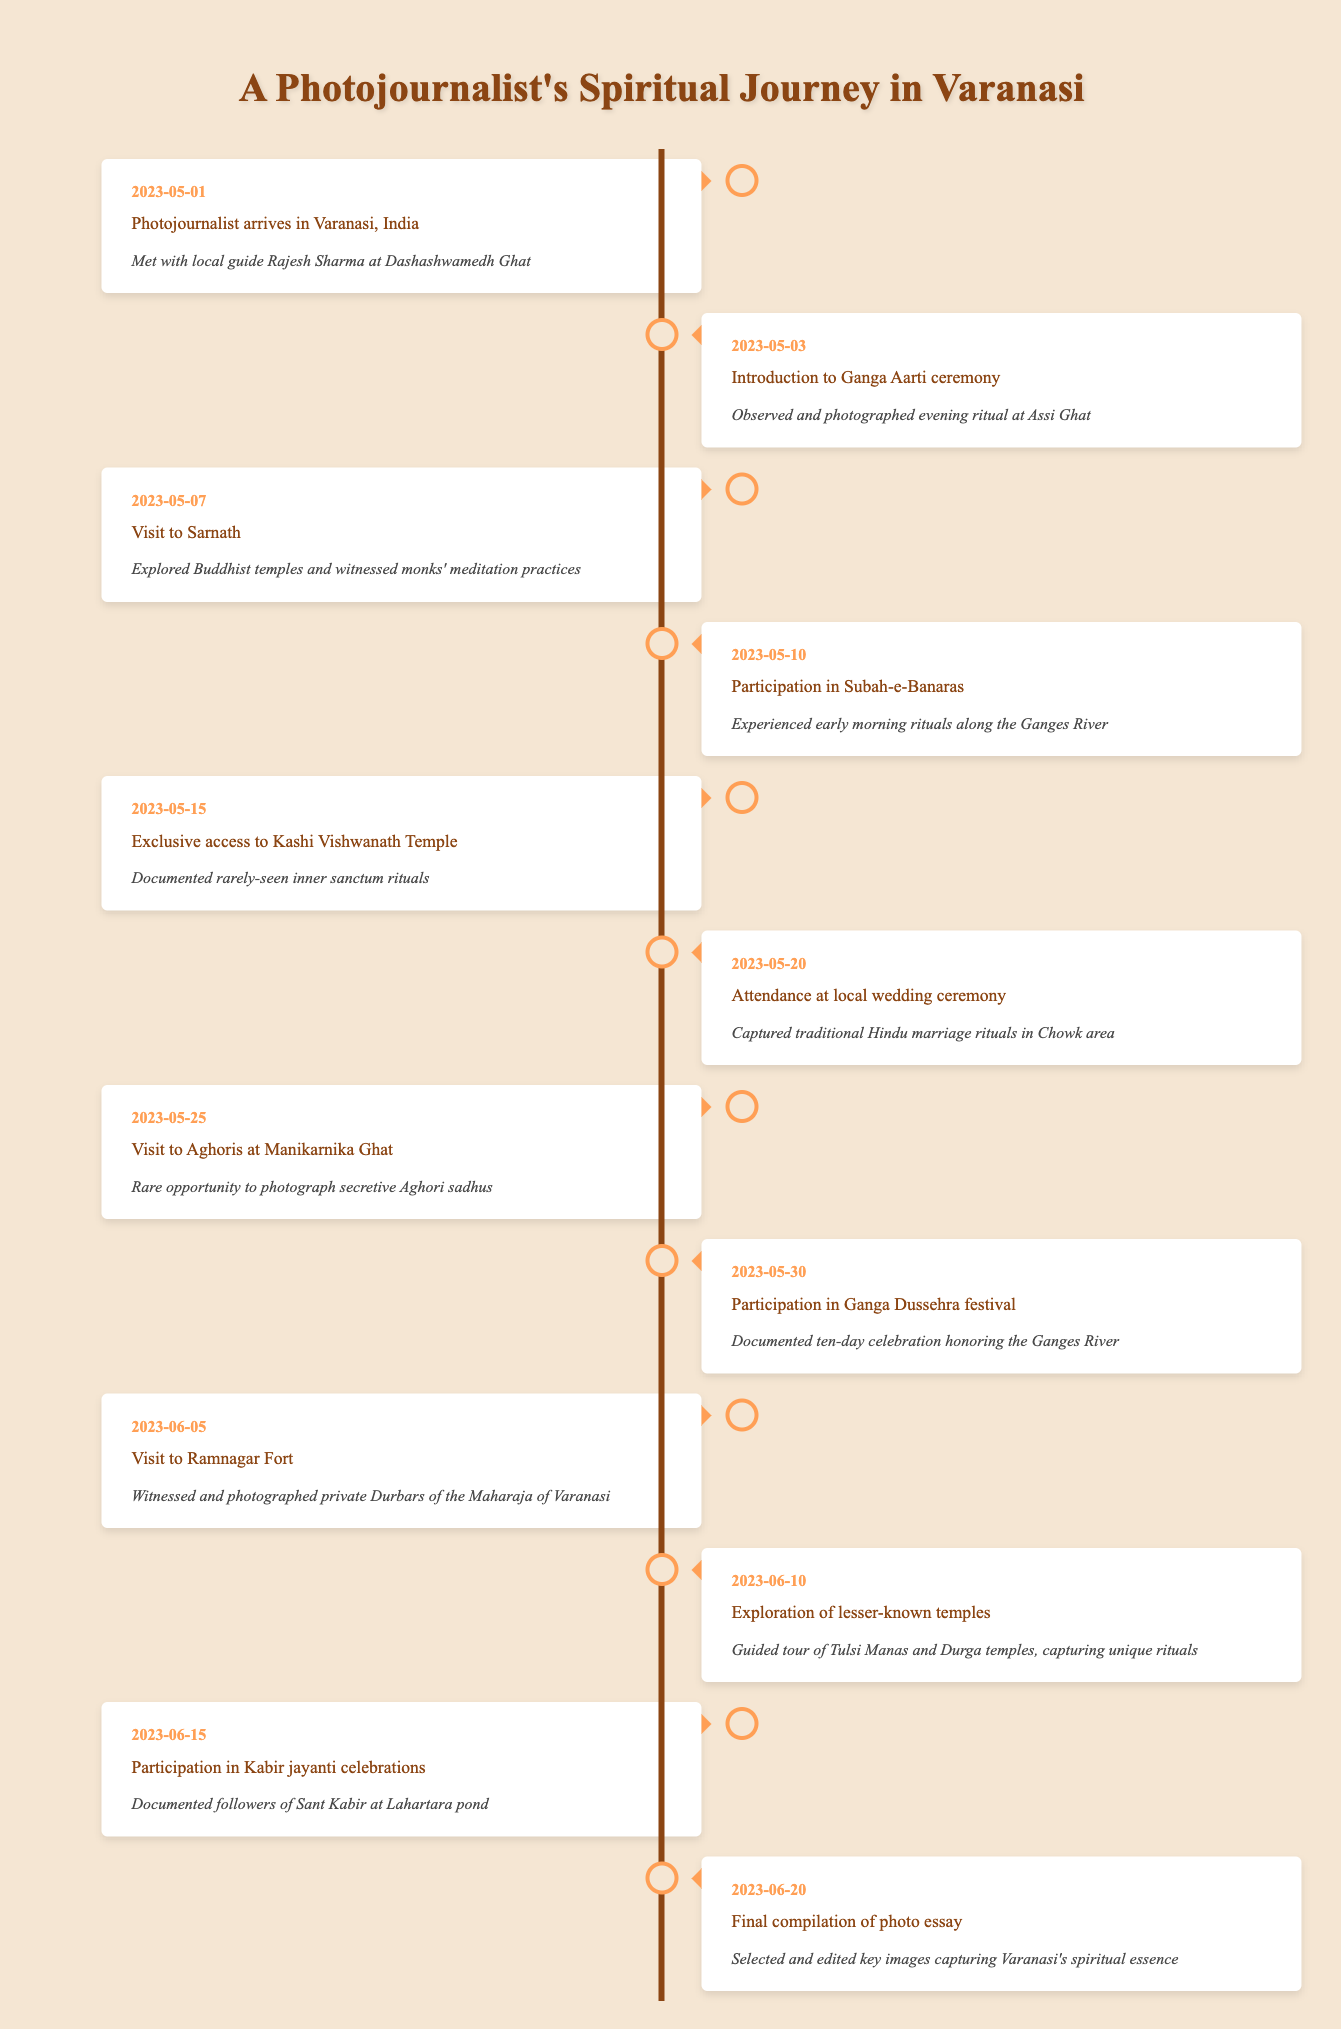What event took place on May 10, 2023? The table shows that on May 10, 2023, the event was "Participation in Subah-e-Banaras."
Answer: Participation in Subah-e-Banaras How many spiritual practices did the photojournalist experience by May 30, 2023? By May 30, 2023, the photojournalist experienced 5 distinct spiritual practices: Ganga Aarti, Sarnath visit, Subah-e-Banaras, Kashi Vishwanath Temple access, and Ganga Dussehra festival.
Answer: 5 Was the photojournalist able to document rituals at Kashi Vishwanath Temple? Yes, the photojournalist had exclusive access to document rarely-seen inner sanctum rituals at Kashi Vishwanath Temple.
Answer: Yes On what date did the photojournalist participate in the Ganga Dussehra festival? According to the table, the participation in the Ganga Dussehra festival took place on May 30, 2023.
Answer: May 30, 2023 What was the last event listed in the timeline? The last event in the timeline is "Final compilation of photo essay," which occurred on June 20, 2023.
Answer: Final compilation of photo essay How many days passed between the photojournalist’s arrival in Varanasi and the attendance at the local wedding ceremony? The photojournalist arrived in Varanasi on May 1, 2023, and attended the wedding ceremony on May 20, 2023. This is a duration of 19 days.
Answer: 19 days Did the photojournalist document any events related to Sant Kabir? Yes, the photojournalist participated in Kabir jayanti celebrations on June 15, 2023, documenting followers of Sant Kabir.
Answer: Yes Which two events occurred in the second week of May? The two events that occurred in the second week of May are the participation in Subah-e-Banaras on May 10 and the attendance at a local wedding ceremony on May 20.
Answer: Subah-e-Banaras; local wedding ceremony Which dates mark visits to temples during the spiritual journey? The photojournalist visited temples on May 15 (Kashi Vishwanath Temple) and June 10 (Tulsi Manas and Durga temples), marking those dates as significant for temple visits.
Answer: May 15; June 10 